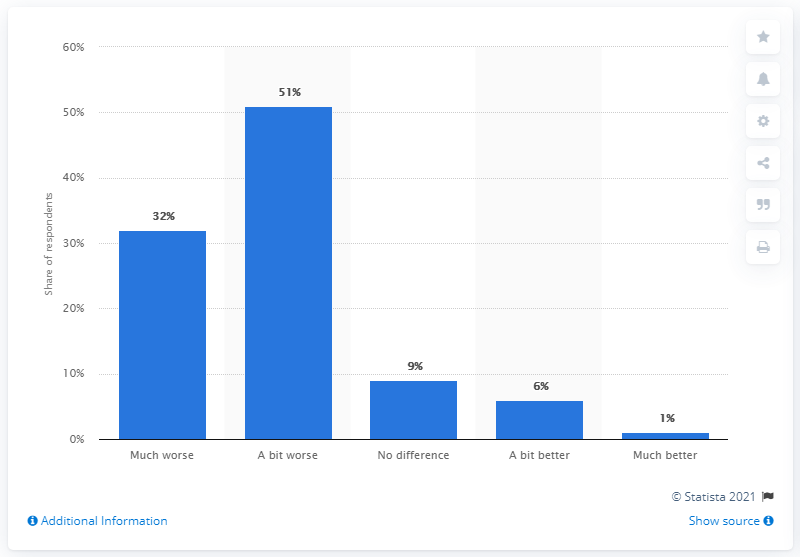Draw attention to some important aspects in this diagram. According to a recent survey, 51% of young people in the UK reported that the current coronavirus pandemic and the resulting public health measures have negatively impacted their mental health. 